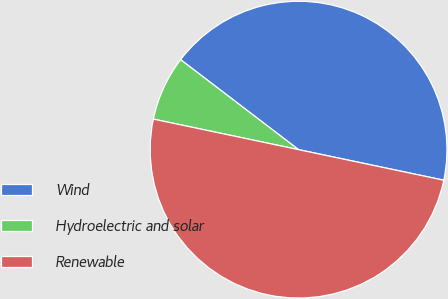<chart> <loc_0><loc_0><loc_500><loc_500><pie_chart><fcel>Wind<fcel>Hydroelectric and solar<fcel>Renewable<nl><fcel>42.93%<fcel>7.07%<fcel>50.0%<nl></chart> 